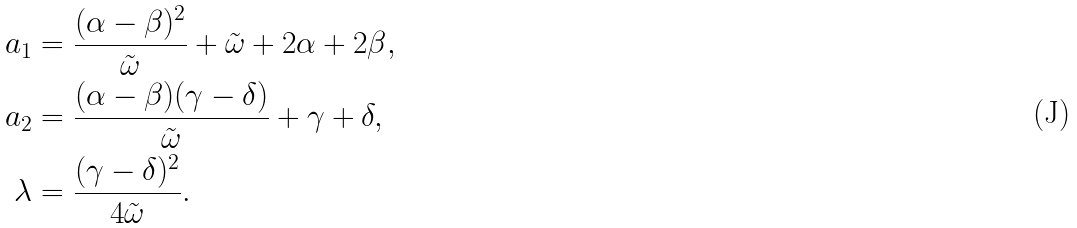Convert formula to latex. <formula><loc_0><loc_0><loc_500><loc_500>a _ { 1 } & = \frac { ( \alpha - \beta ) ^ { 2 } } { \tilde { \omega } } + \tilde { \omega } + 2 \alpha + 2 \beta , \\ a _ { 2 } & = \frac { ( \alpha - \beta ) ( \gamma - \delta ) } { \tilde { \omega } } + \gamma + \delta , \\ \lambda & = \frac { ( \gamma - \delta ) ^ { 2 } } { 4 \tilde { \omega } } .</formula> 